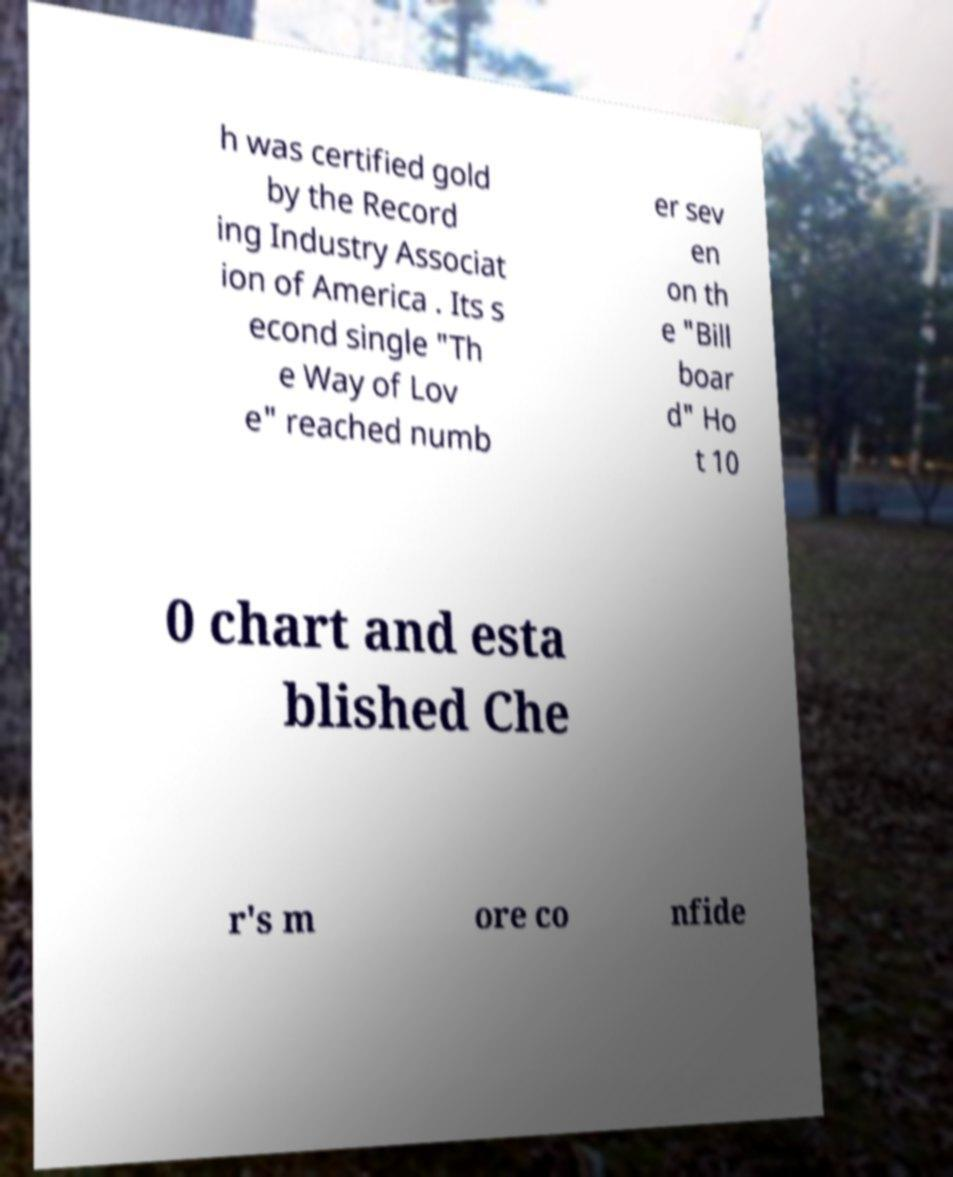Please read and relay the text visible in this image. What does it say? h was certified gold by the Record ing Industry Associat ion of America . Its s econd single "Th e Way of Lov e" reached numb er sev en on th e "Bill boar d" Ho t 10 0 chart and esta blished Che r's m ore co nfide 